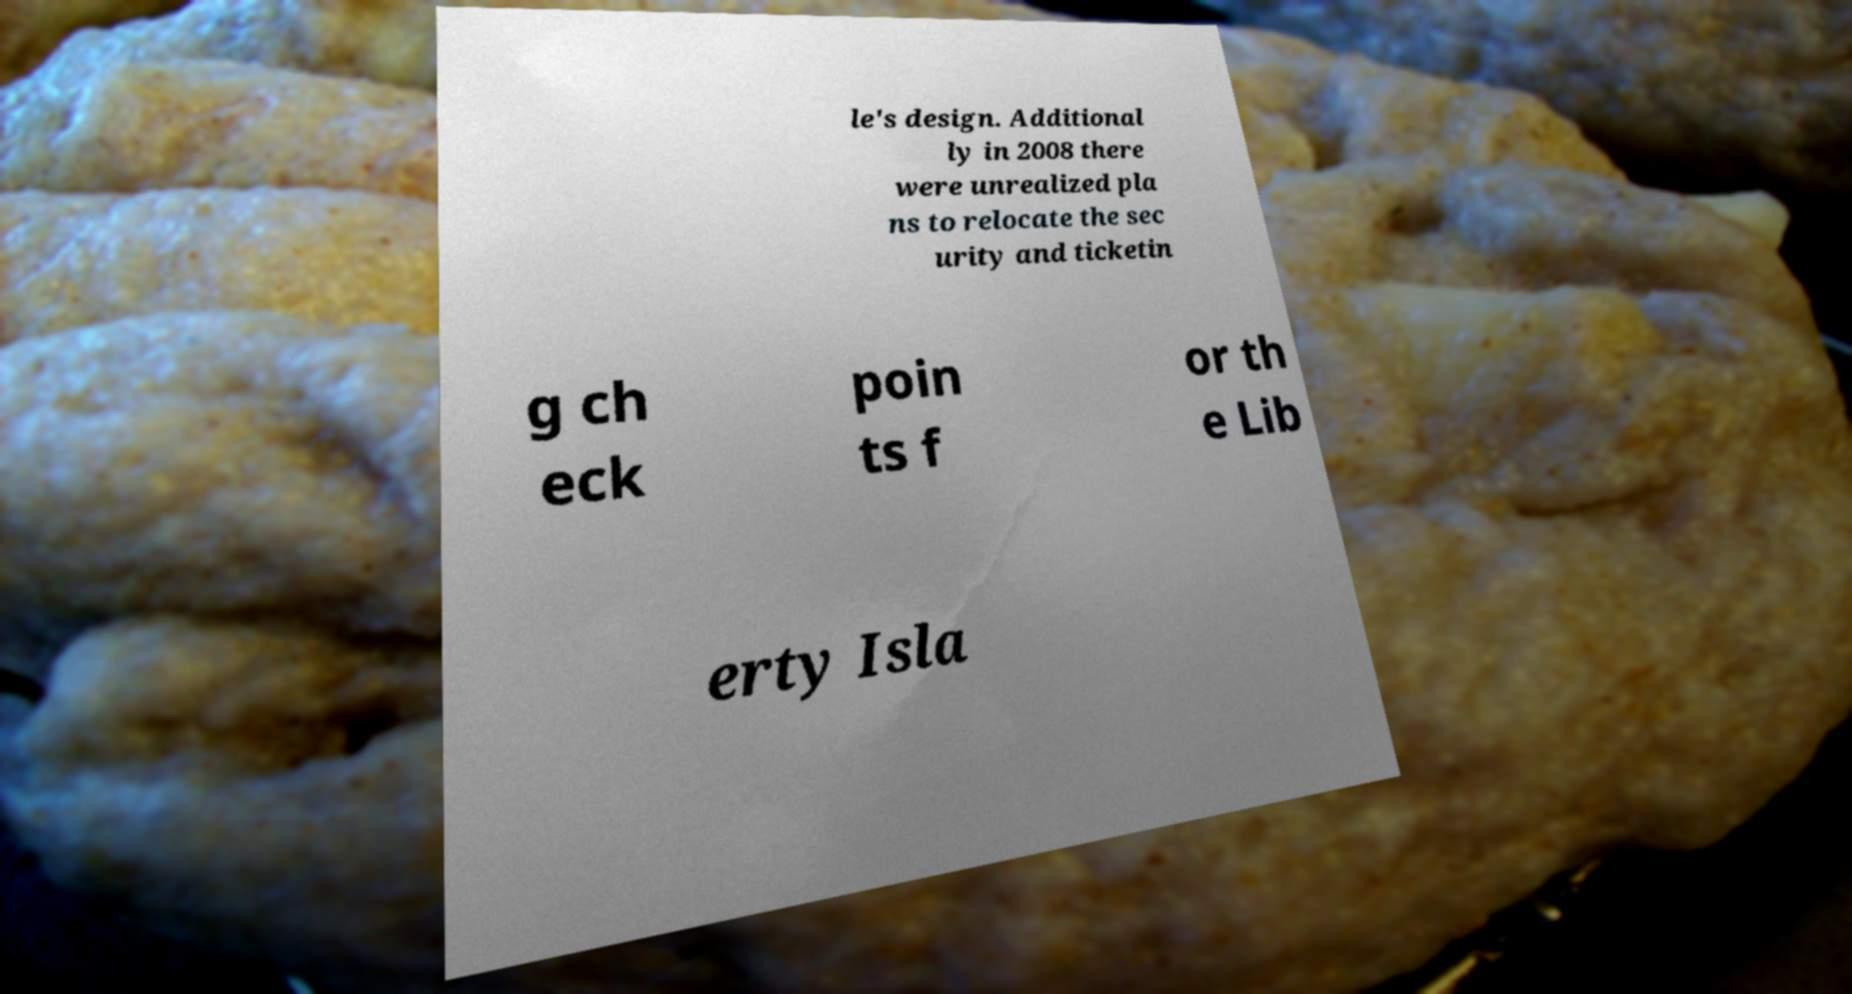I need the written content from this picture converted into text. Can you do that? le's design. Additional ly in 2008 there were unrealized pla ns to relocate the sec urity and ticketin g ch eck poin ts f or th e Lib erty Isla 